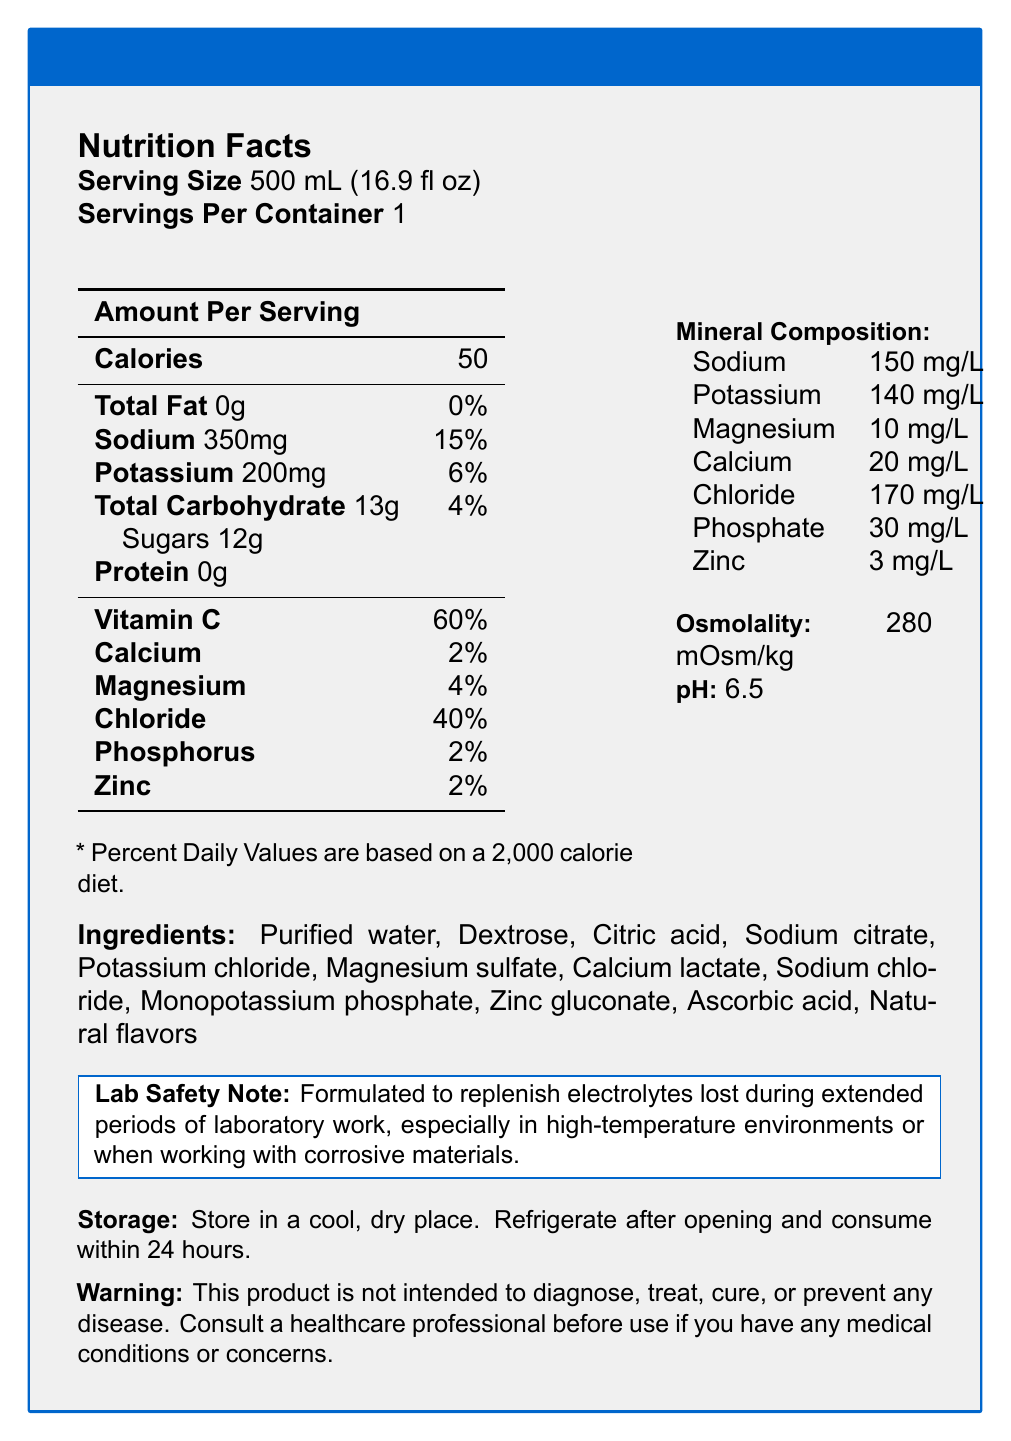what is the serving size of LabCharge Electrolyte Replenisher? The serving size is explicitly stated at the top of the Nutrition Facts section of the document.
Answer: 500 mL (16.9 fl oz) how many calories are there per serving? The document shows that one serving of LabCharge Electrolyte Replenisher contains 50 calories, which is listed under the "Calories" section.
Answer: 50 how much sodium is in a 500 mL serving of the sports drink? The sodium content for one serving is listed as 350 mg in the Nutrition Facts section of the document.
Answer: 350 mg what percent daily value of Vitamin C does a serving provide? The Percent Daily Value provided by one serving of Vitamin C is listed as 60% in the Nutrition Facts.
Answer: 60% what is the osmolality of the product? The osmolality is specifically mentioned in the sidebar portion of the document under "Mineral Composition."
Answer: 280 mOsm/kg how many grams of sugars are in one serving? The document lists the sugar content as 12 grams under the "Total Carbohydrate" section.
Answer: 12 grams how many minerals are detailed in the mineral composition section? Seven minerals are listed: sodium, potassium, magnesium, calcium, chloride, phosphate, and zinc.
Answer: Seven which of the following ingredients is not in LabCharge Electrolyte Replenisher?
A. Purified water  
B. Sodium citrate  
C. Caffeine  
D. Zinc gluconate The ingredients listed do not include caffeine but do include purified water, sodium citrate, and zinc gluconate.
Answer: C. Caffeine approximately how much potassium is there per liter in the product?  
A. 100 mg/L  
B. 120 mg/L  
C. 140 mg/L  
D. 160 mg/L The mineral composition section lists potassium at 140 mg/L.
Answer: C. 140 mg/L does this product contain protein? The document explicitly states that the product contains 0 grams of protein per serving.
Answer: No summarize the nutritional highlights and purpose of LabCharge Electrolyte Replenisher. The document outlines the nutritional contents and emphasizes its utility in a lab setting.
Answer: LabCharge Electrolyte Replenisher is a low-calorie sports drink formulated to replenish electrolytes lost during lab work, especially in high-temperature environments or when using corrosive materials. It contains sodium, potassium, magnesium, calcium, chloride, phosphate, and zinc. Additionally, it has a moderate amount of carbohydrates and Vitamin C. what is the recommended pH level of LabCharge Electrolyte Replenisher? The pH level is stated in the document as 6.5 in the sidebar under the mineral composition.
Answer: 6.5 what storage instructions are provided for this product? The storage instructions are written at the bottom of the document.
Answer: Store in a cool, dry place. Refrigerate after opening and consume within 24 hours. what percent daily value of calcium is provided by one serving? The Nutrition Facts section lists calcium as providing 2% of the daily value.
Answer: 2% how much chloride is there per serving (in mg)? The document only provides chloride in terms of mg/L (170 mg/L) and not per serving.
Answer: Not enough information is Vitamin D included in the nutritional facts? Vitamin D is not mentioned anywhere in the Nutrition Facts section of the document.
Answer: No 